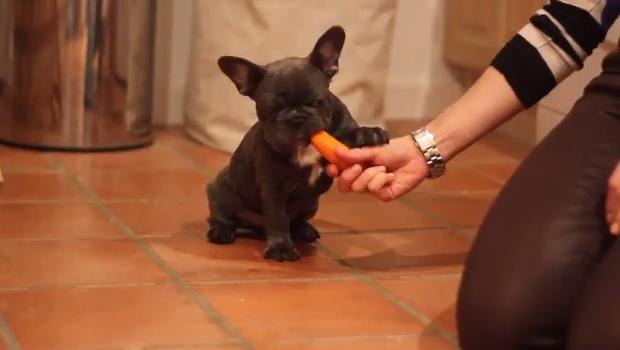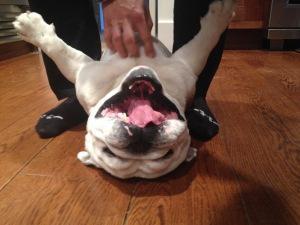The first image is the image on the left, the second image is the image on the right. For the images shown, is this caption "There are puppies in each image." true? Answer yes or no. No. 